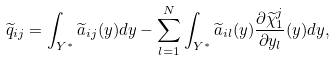<formula> <loc_0><loc_0><loc_500><loc_500>\widetilde { q } _ { i j } = \int _ { Y ^ { * } } \widetilde { a } _ { i j } ( y ) d y - \sum _ { l = 1 } ^ { N } \int _ { Y ^ { * } } \widetilde { a } _ { i l } ( y ) \frac { \partial \widetilde { \chi } ^ { j } _ { 1 } } { \partial y _ { l } } ( y ) d y ,</formula> 